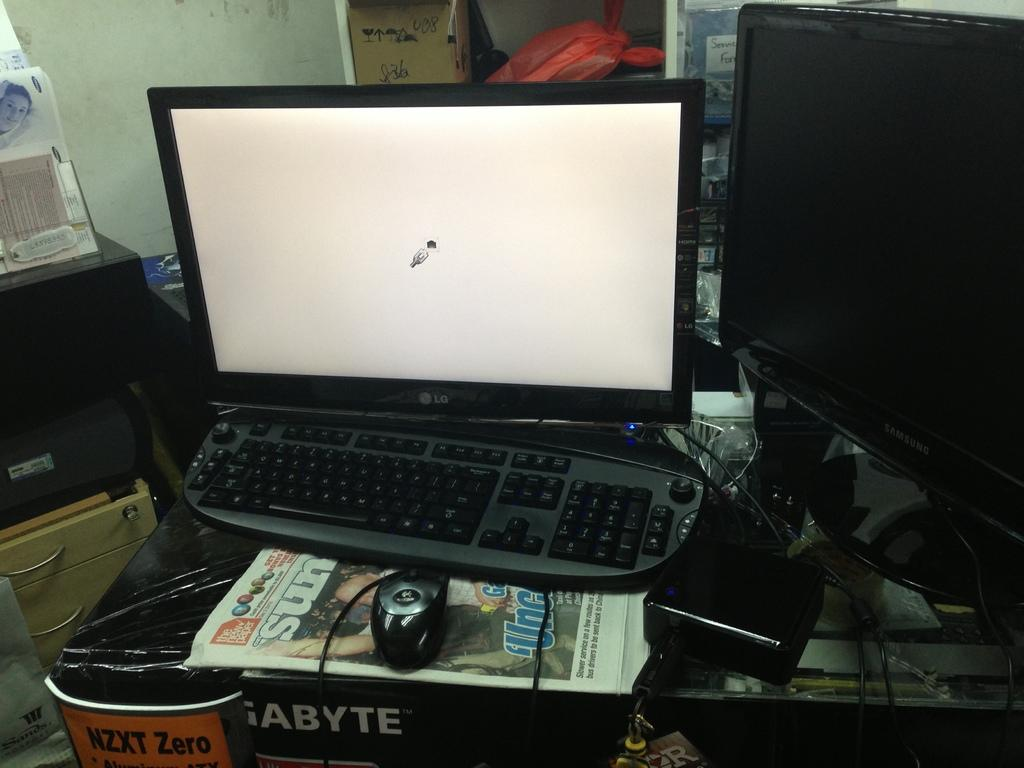<image>
Offer a succinct explanation of the picture presented. An LG monitor sits behind a black keyboard and a mouse. 